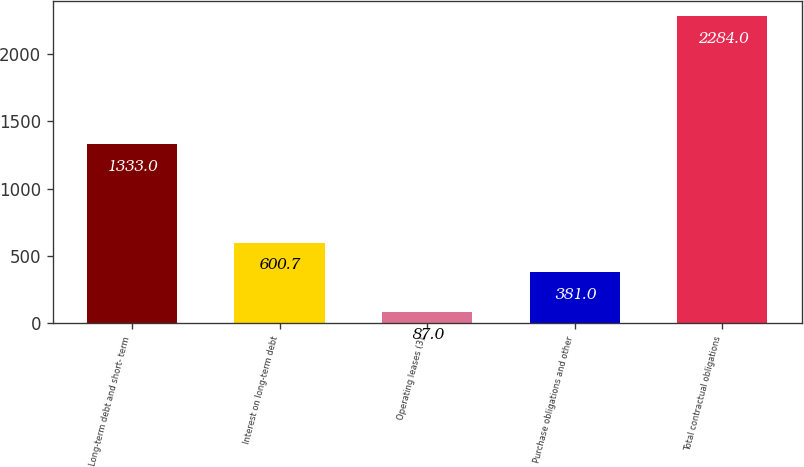Convert chart. <chart><loc_0><loc_0><loc_500><loc_500><bar_chart><fcel>Long-term debt and short- term<fcel>Interest on long-term debt<fcel>Operating leases (3)<fcel>Purchase obligations and other<fcel>Total contractual obligations<nl><fcel>1333<fcel>600.7<fcel>87<fcel>381<fcel>2284<nl></chart> 